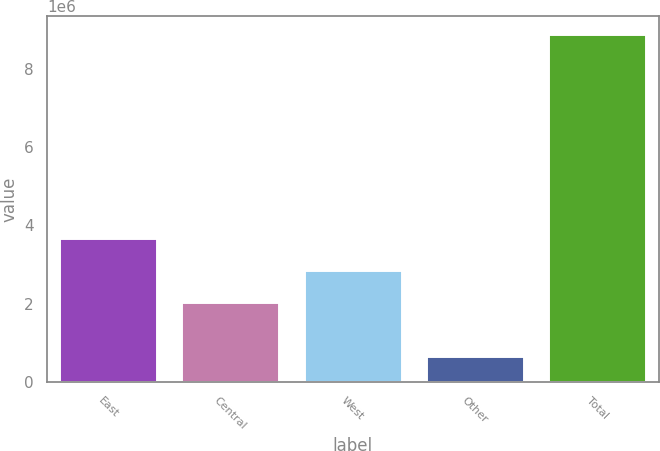Convert chart. <chart><loc_0><loc_0><loc_500><loc_500><bar_chart><fcel>East<fcel>Central<fcel>West<fcel>Other<fcel>Total<nl><fcel>3.68238e+06<fcel>2.03734e+06<fcel>2.85986e+06<fcel>663247<fcel>8.88848e+06<nl></chart> 